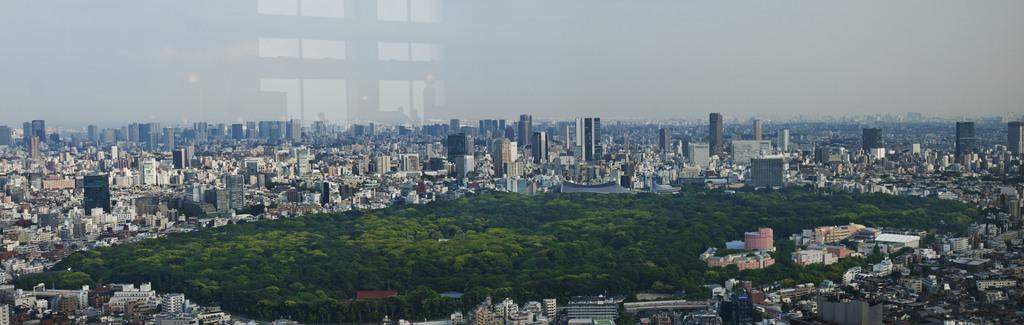What type of location is depicted in the image? The image is of a city. What structures can be seen in the city? There are buildings in the image. Are there any natural elements present in the city? Yes, there are trees in the image. What can be seen in the distance in the image? The sky is visible in the background of the image. How many light bulbs are hanging from the trees in the image? There are no light bulbs present in the image; it features a city with buildings, trees, and a visible sky. What type of knife can be seen being used in the image? There is no knife present in the image. 